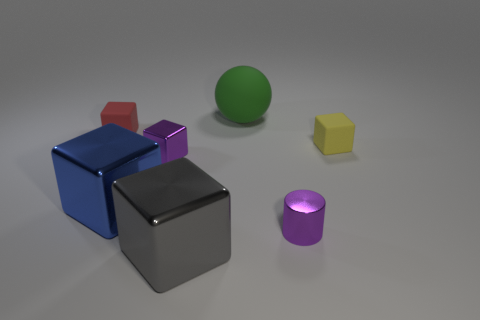What do the different sizes and shapes of the objects in the image suggest about their arrangement? The varied sizes and shapes of the objects might indicate an organized diversity, where each object has been placed deliberately to contribute to the overall composition. The larger blocks form a grounding base, while the smaller and uniquely shaped objects add visual interest, creating a dynamic and harmonious arrangement. 